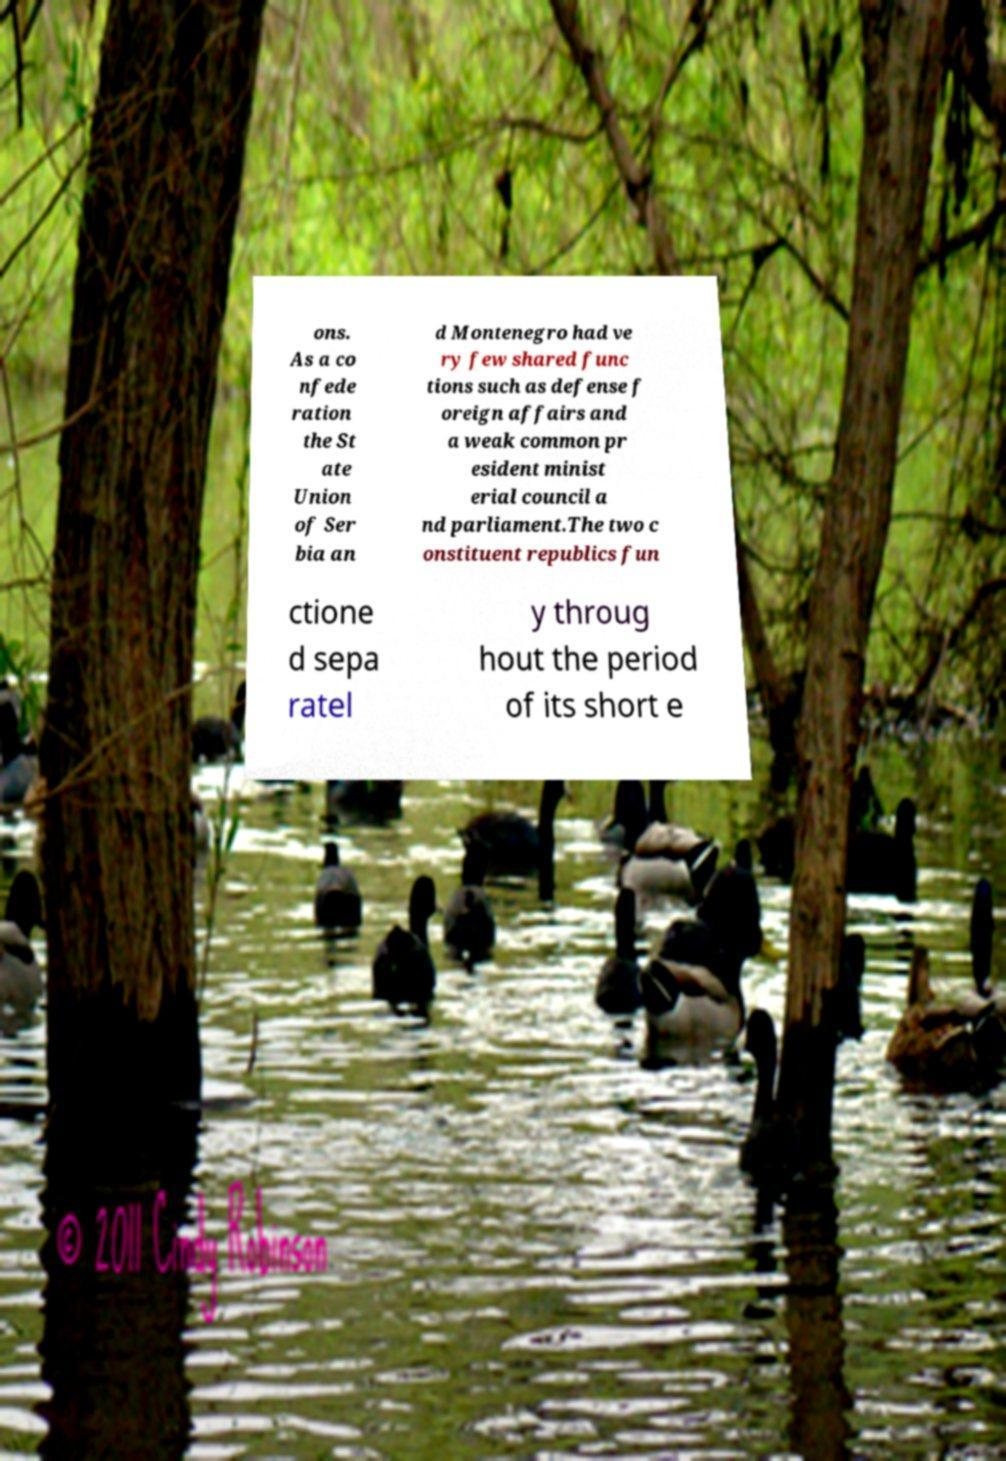Please identify and transcribe the text found in this image. ons. As a co nfede ration the St ate Union of Ser bia an d Montenegro had ve ry few shared func tions such as defense f oreign affairs and a weak common pr esident minist erial council a nd parliament.The two c onstituent republics fun ctione d sepa ratel y throug hout the period of its short e 